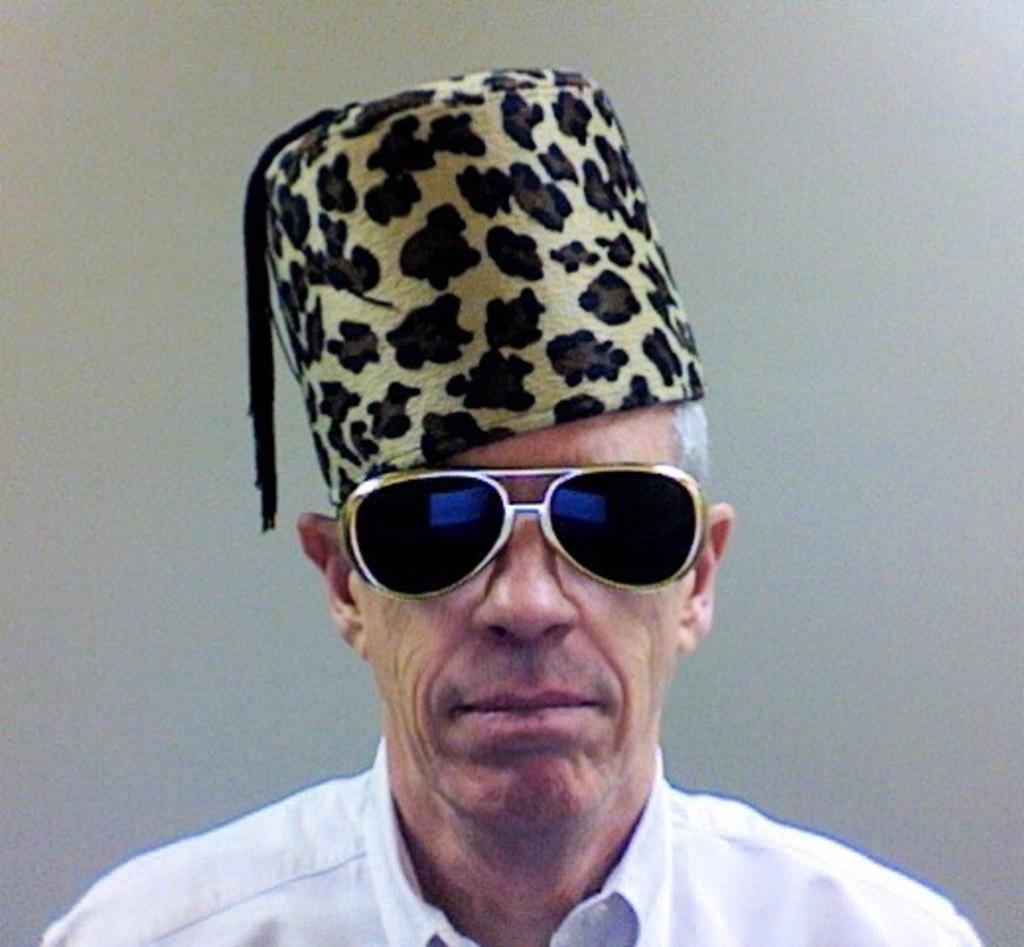Who or what can be seen in the image? There is a person present in the image. What accessory is the person wearing on their face? The person is wearing spectacles. What type of headwear is the person wearing? The person is wearing a cap on their head. What time of day is it in the image, and are there any geese present? The provided facts do not mention the time of day or the presence of geese in the image. 